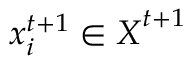Convert formula to latex. <formula><loc_0><loc_0><loc_500><loc_500>x _ { i } ^ { t + 1 } \in X ^ { t + 1 }</formula> 